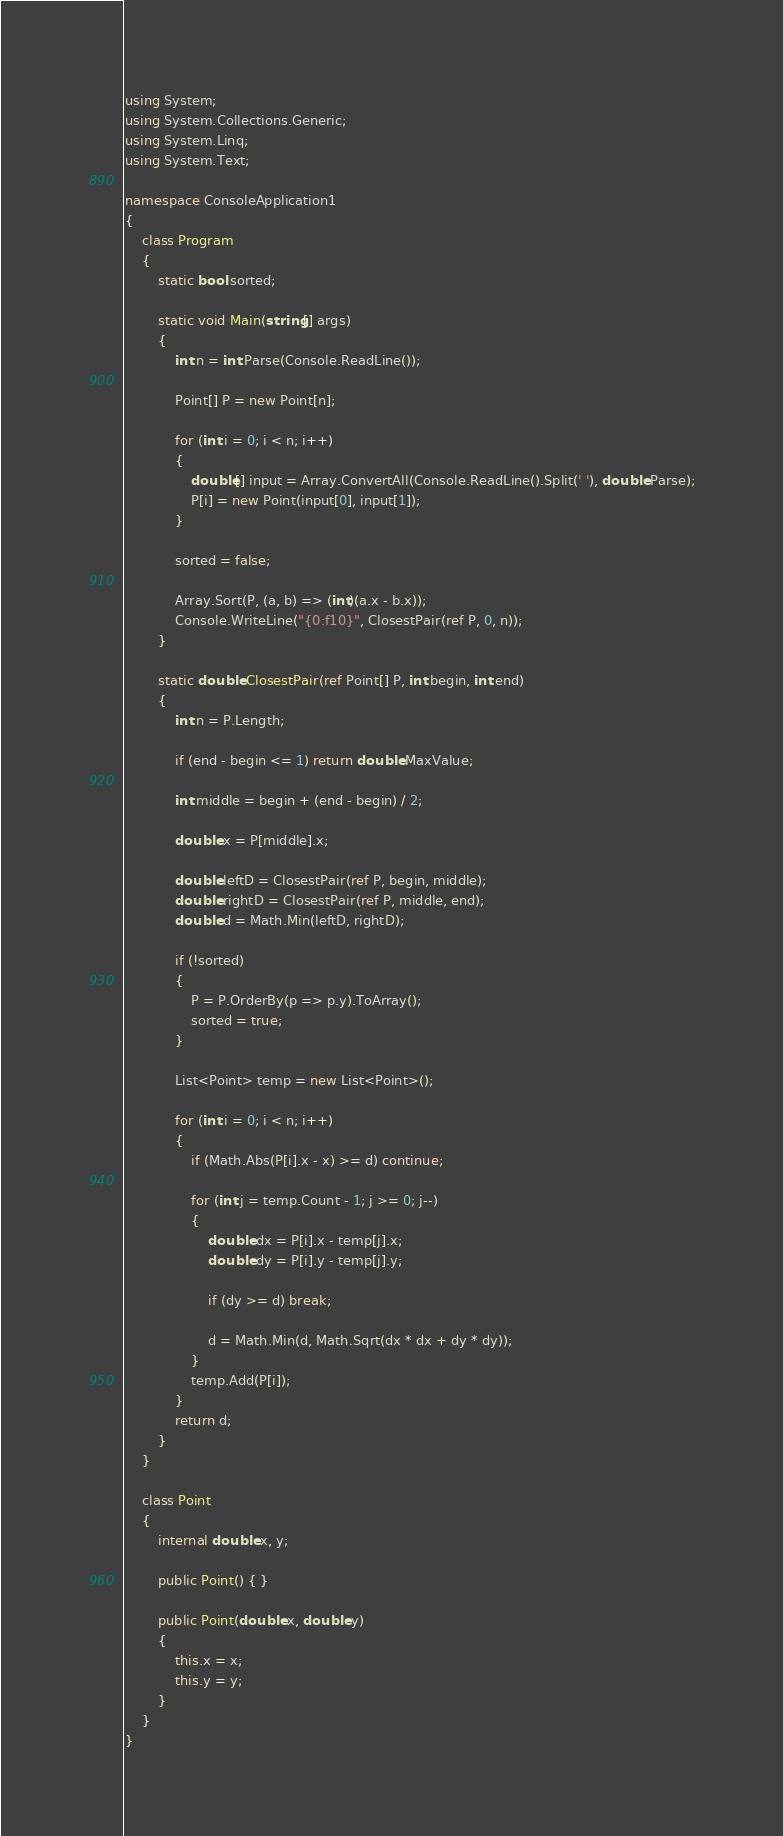Convert code to text. <code><loc_0><loc_0><loc_500><loc_500><_C#_>using System;
using System.Collections.Generic;
using System.Linq;
using System.Text;

namespace ConsoleApplication1
{
    class Program
    {
        static bool sorted;

        static void Main(string[] args)
        {
            int n = int.Parse(Console.ReadLine());

            Point[] P = new Point[n];

            for (int i = 0; i < n; i++)
            {
                double[] input = Array.ConvertAll(Console.ReadLine().Split(' '), double.Parse);
                P[i] = new Point(input[0], input[1]);
            }

            sorted = false;

            Array.Sort(P, (a, b) => (int)(a.x - b.x));
            Console.WriteLine("{0:f10}", ClosestPair(ref P, 0, n));
        }

        static double ClosestPair(ref Point[] P, int begin, int end)
        {
            int n = P.Length;

            if (end - begin <= 1) return double.MaxValue;

            int middle = begin + (end - begin) / 2;

            double x = P[middle].x;

            double leftD = ClosestPair(ref P, begin, middle);
            double rightD = ClosestPair(ref P, middle, end);
            double d = Math.Min(leftD, rightD);

            if (!sorted)
            {
                P = P.OrderBy(p => p.y).ToArray();
                sorted = true;
            }

            List<Point> temp = new List<Point>();

            for (int i = 0; i < n; i++)
            {
                if (Math.Abs(P[i].x - x) >= d) continue;

                for (int j = temp.Count - 1; j >= 0; j--)
                {
                    double dx = P[i].x - temp[j].x;
                    double dy = P[i].y - temp[j].y;

                    if (dy >= d) break;

                    d = Math.Min(d, Math.Sqrt(dx * dx + dy * dy));
                }
                temp.Add(P[i]);
            }
            return d;
        }
    }

    class Point
    {
        internal double x, y;

        public Point() { }

        public Point(double x, double y)
        {
            this.x = x;
            this.y = y;
        }
    }
}</code> 